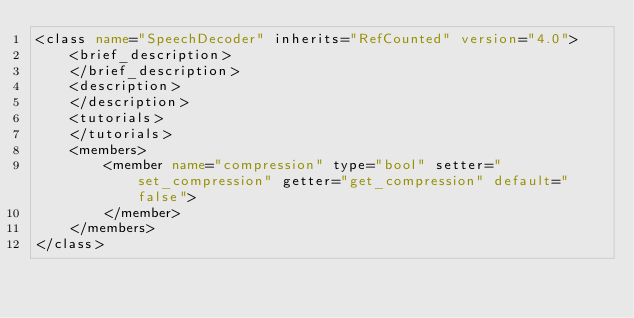Convert code to text. <code><loc_0><loc_0><loc_500><loc_500><_XML_><class name="SpeechDecoder" inherits="RefCounted" version="4.0">
	<brief_description>
	</brief_description>
	<description>
	</description>
	<tutorials>
	</tutorials>
	<members>
		<member name="compression" type="bool" setter="set_compression" getter="get_compression" default="false">
		</member>
	</members>
</class>
</code> 